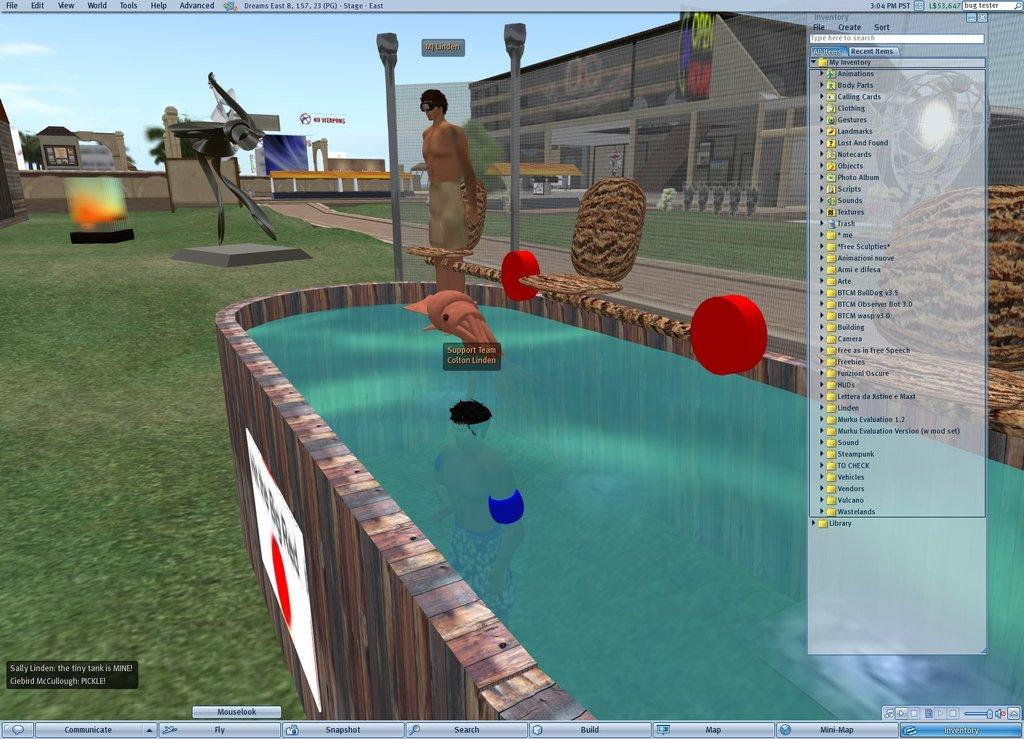What is the main object in the image? There is a monitor screen in the image. What can be seen on the monitor screen? The monitor screen displays a person. What is the container in the image holding? There is a container with water in the image. What type of structures are visible in the image? There are poles and buildings in the image. What type of natural environment is visible in the image? There is grass in the image. What part of the natural environment is visible in the image? The sky is visible in the image. What type of ornament is hanging from the monitor screen in the image? There is no ornament hanging from the monitor screen in the image. Is there a party happening in the image? There is no indication of a party in the image. 